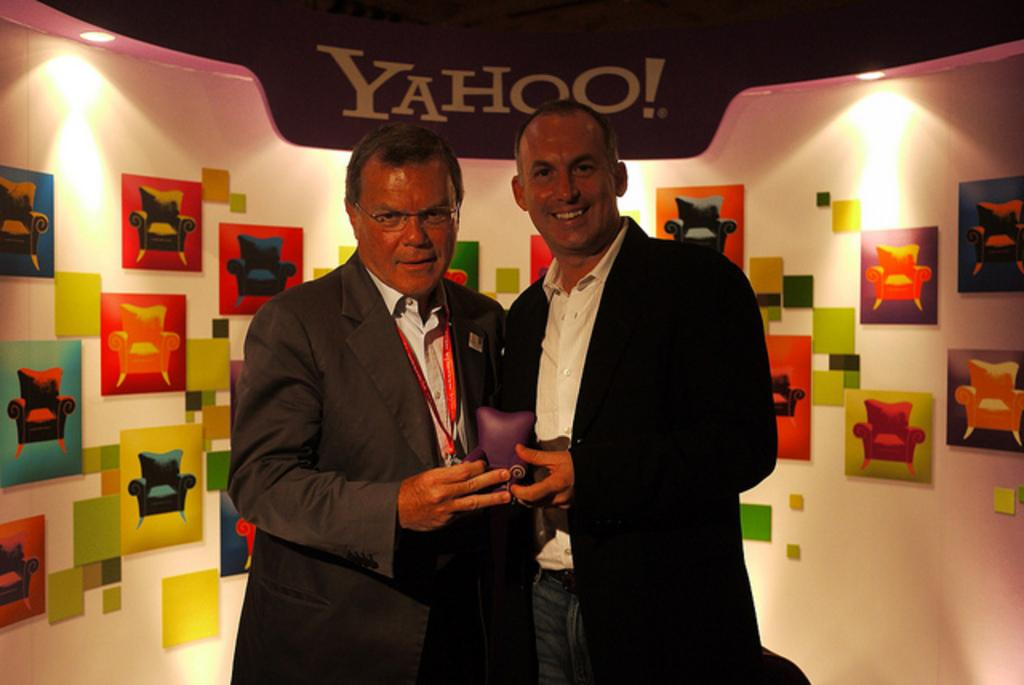How many people are in the image? There are two people in the image. What are the people doing in the image? The people are smiling and holding an object. What can be seen in the background of the image? There is a wall in the background of the image. What is on the wall in the image? The wall has paintings, lights, and some text on it. Where is the sofa located in the image? There is no sofa present in the image. Do the people have fangs in the image? There is no indication of fangs on the people in the image. 